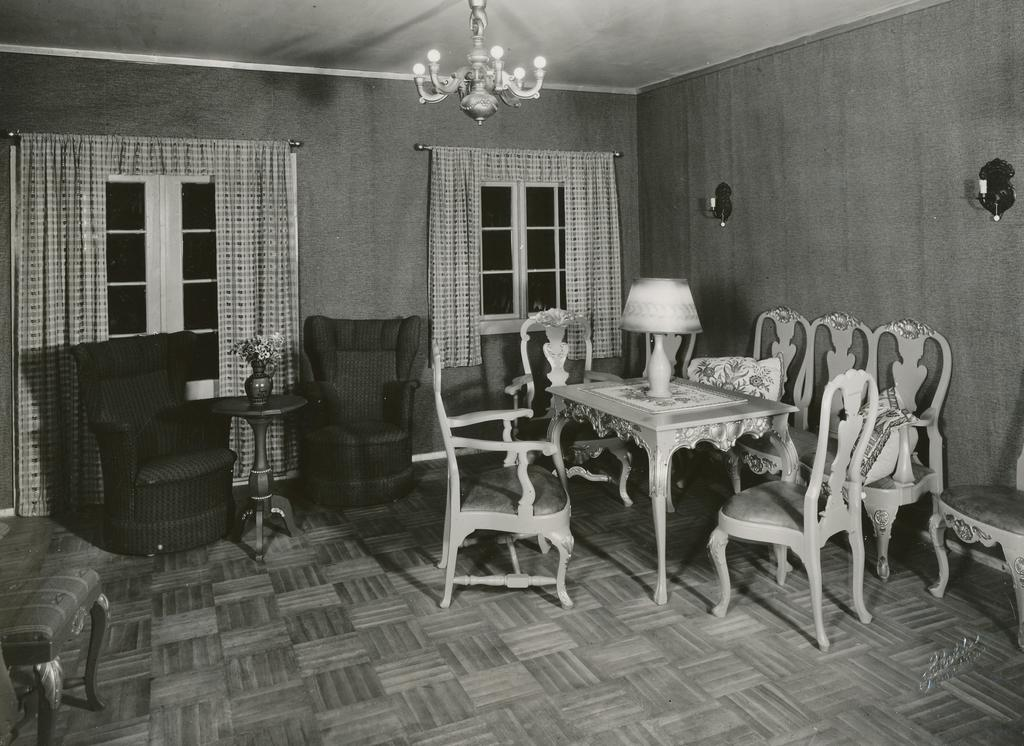What is the color scheme of the image? The image is black and white. What type of furniture can be seen in the image? There are chairs and tables in the image. What type of lighting is present in the image? There is a lamp, a chandelier, and lights in the image. What type of decorative item is present in the image? There is a flower vase in the image. What type of window treatment is present in the image? There are curtains in the image. What type of architectural feature is present in the image? There are windows in the image. What is the reaction of the actor in the image? There is no actor present in the image, so it is not possible to determine their reaction. 